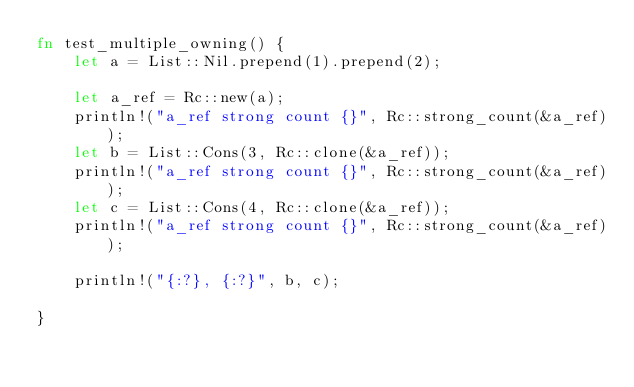Convert code to text. <code><loc_0><loc_0><loc_500><loc_500><_Rust_>fn test_multiple_owning() {
    let a = List::Nil.prepend(1).prepend(2);

    let a_ref = Rc::new(a);
    println!("a_ref strong count {}", Rc::strong_count(&a_ref));
    let b = List::Cons(3, Rc::clone(&a_ref));
    println!("a_ref strong count {}", Rc::strong_count(&a_ref));
    let c = List::Cons(4, Rc::clone(&a_ref));
    println!("a_ref strong count {}", Rc::strong_count(&a_ref));

    println!("{:?}, {:?}", b, c);

}</code> 